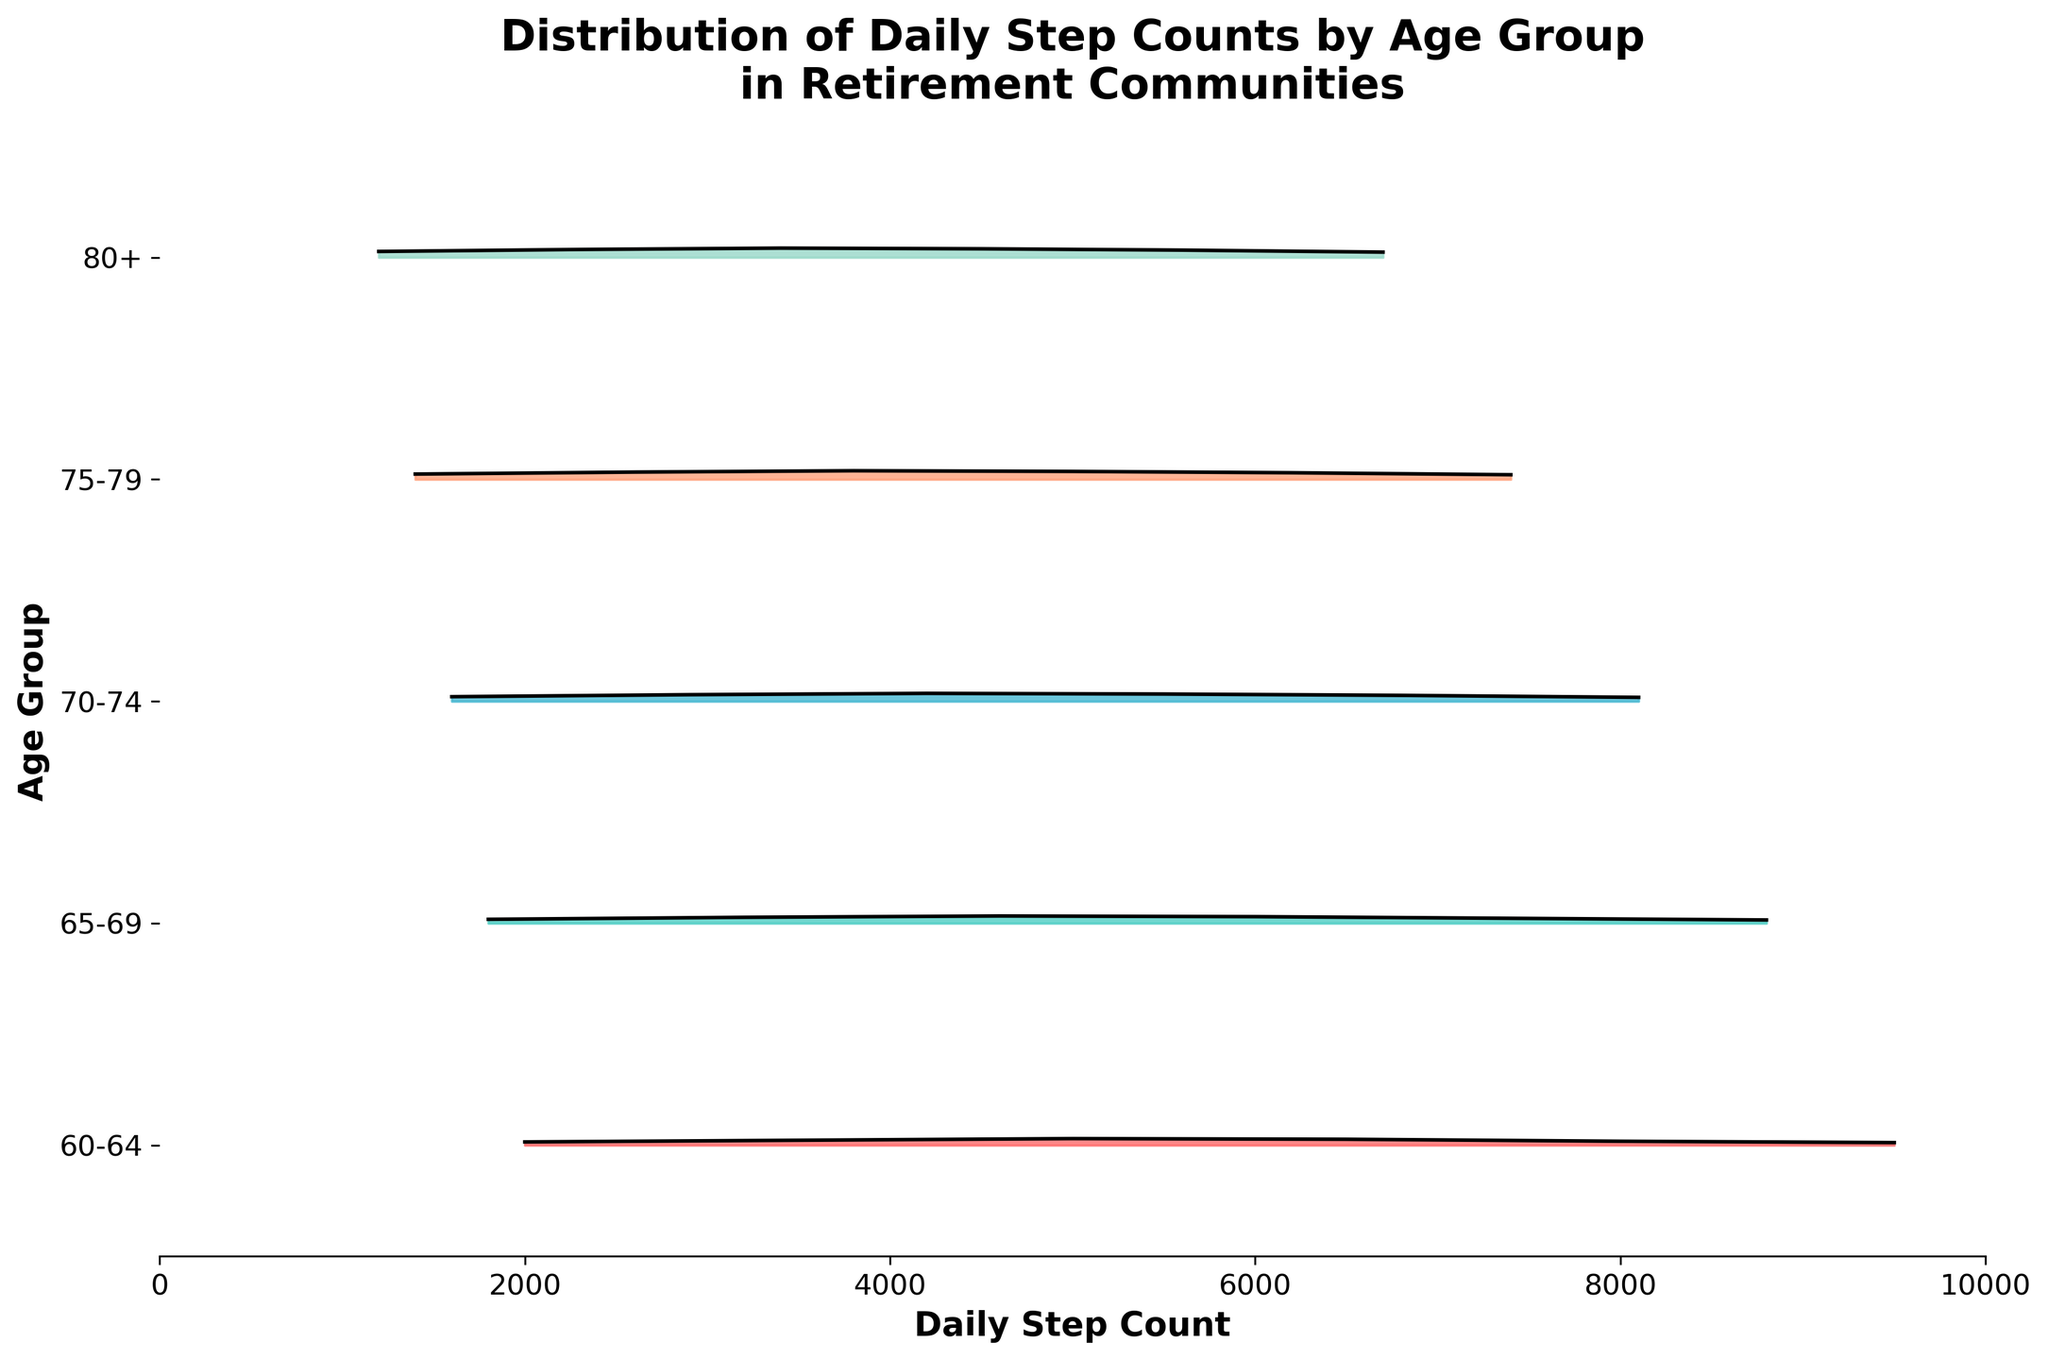What is the title of the plot? The title of the plot is usually displayed at the top of the figure. In this case, it is describing the data being visualized and the context.
Answer: Distribution of Daily Step Counts by Age Group in Retirement Communities What is the x-axis label? The x-axis label explains what the values on the x-axis represent. In this case, it represents the daily step counts of individuals.
Answer: Daily Step Count How many age groups are displayed in the plot? Each distinct color band or segment corresponds to a different age group. By counting these bands, we can determine the number of groups.
Answer: 5 Which age group has the widest range of daily step counts? The age group with the widest range will have its colored area stretched the furthest along the x-axis.
Answer: 60-64 Which age group shows the highest density at 4200 steps? By looking at where the density curves peak around 4200 steps, we can identify which age group has the highest density value at that point.
Answer: 70-74 Between which two age groups is there the biggest difference in peak density values? Analyze the height and spread of the density curves to determine which two groups have the most contrasting peak densities.
Answer: 70-74 and 80+ Which age group shows the lowest density at 5000 steps? By observing the densities at 5000 steps across the groups, the group with the smallest peak or area around 5000 steps can be identified.
Answer: 60-64 At approximately what step count does the age group 65-69 show its highest density? Look at the peak position of the 65-69 group’s density curve to determine this.
Answer: 4600 How do the densities at 2900 steps compare among the different age groups? Observe the height and spread of the density curves at the 2900-step mark for each age group to compare.
Answer: 70-74 has the highest density, followed by 80+, 75-79, then 65-69 and 60-64 What is the trend in daily step counts as age increases from 60-64 to 80+? By observing the shifts and shapes of the density curves for each consecutive age group, we can describe the overall trend.
Answer: Step counts generally decrease with age, with younger groups showing higher step counts and densities 